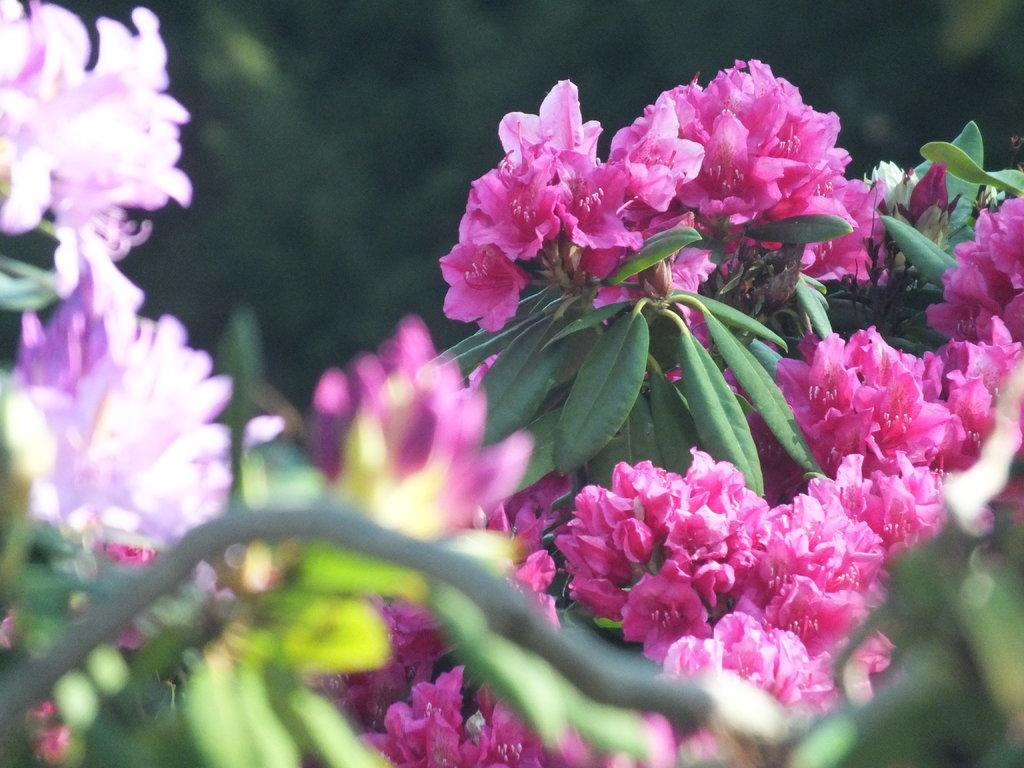What type of vegetation can be seen in the image? There are plants in the image. What specific part of the plants can be observed? There are flowers and leaves in the image. Is there a volcano erupting in the background of the image? No, there is no volcano present in the image. How many flies can be seen buzzing around the flowers in the image? There are no flies visible in the image. 